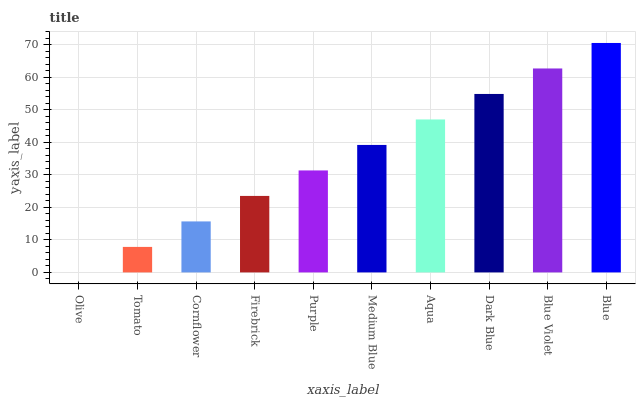Is Tomato the minimum?
Answer yes or no. No. Is Tomato the maximum?
Answer yes or no. No. Is Tomato greater than Olive?
Answer yes or no. Yes. Is Olive less than Tomato?
Answer yes or no. Yes. Is Olive greater than Tomato?
Answer yes or no. No. Is Tomato less than Olive?
Answer yes or no. No. Is Medium Blue the high median?
Answer yes or no. Yes. Is Purple the low median?
Answer yes or no. Yes. Is Blue Violet the high median?
Answer yes or no. No. Is Blue the low median?
Answer yes or no. No. 